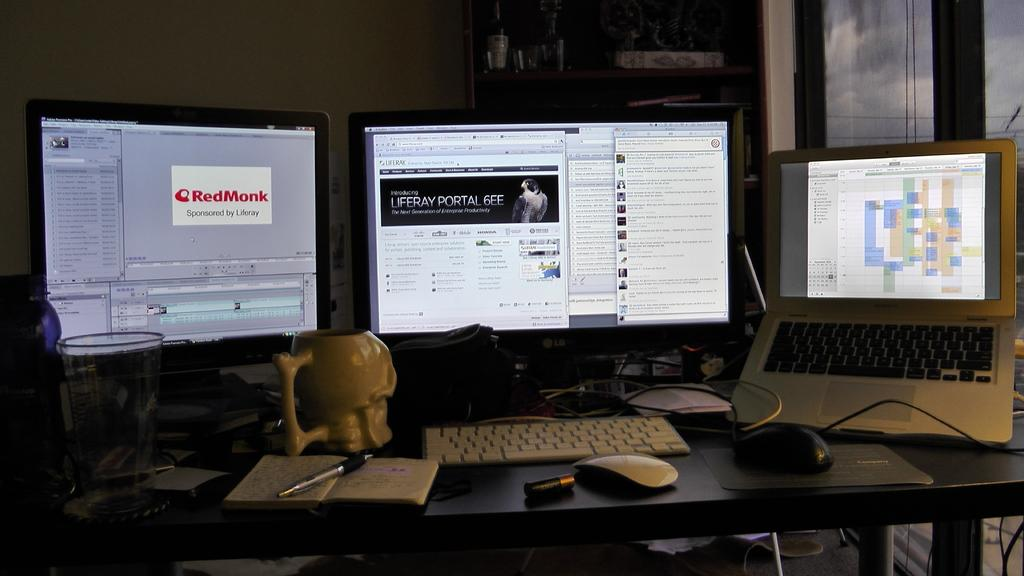<image>
Render a clear and concise summary of the photo. Three computer monitors are on a desk with the leftmost one displaying the text RedMonk. 